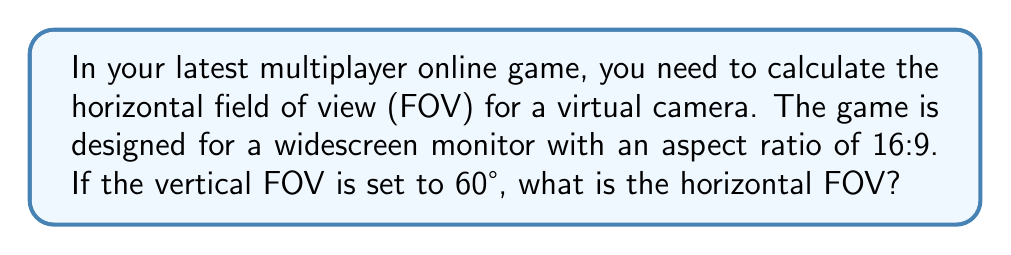Show me your answer to this math problem. To solve this problem, we'll follow these steps:

1) First, recall the formula for calculating horizontal FOV from vertical FOV:

   $$\tan(\frac{\text{HFOV}}{2}) = \frac{\text{aspect ratio}}{\tan(\frac{\text{VFOV}}{2})} \cdot \tan(\frac{\text{VFOV}}{2})$$

2) We're given:
   - Aspect ratio = 16:9
   - Vertical FOV (VFOV) = 60°

3) Let's substitute these values:

   $$\tan(\frac{\text{HFOV}}{2}) = \frac{16}{9} \cdot \tan(30°)$$

4) Calculate $\tan(30°)$:
   
   $$\tan(30°) = \frac{1}{\sqrt{3}} \approx 0.5774$$

5) Substitute this value:

   $$\tan(\frac{\text{HFOV}}{2}) = \frac{16}{9} \cdot 0.5774 \approx 1.0243$$

6) Now we need to solve for HFOV:

   $$\frac{\text{HFOV}}{2} = \arctan(1.0243)$$

7) Calculate this:

   $$\frac{\text{HFOV}}{2} \approx 45.6°$$

8) Finally, multiply by 2 to get the full HFOV:

   $$\text{HFOV} \approx 45.6° \cdot 2 = 91.2°$$

Therefore, the horizontal field of view is approximately 91.2°.
Answer: 91.2° 